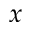Convert formula to latex. <formula><loc_0><loc_0><loc_500><loc_500>x</formula> 